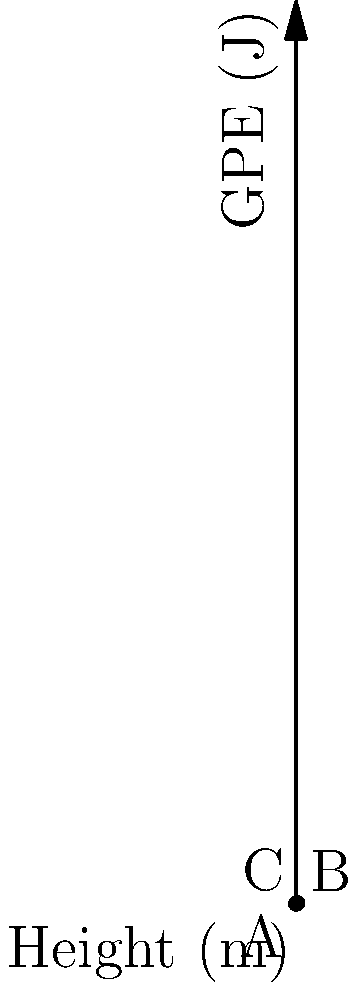A surfer of mass 70 kg is riding a wave as shown in the diagram. Calculate the difference in gravitational potential energy between points C and B. Assume $g = 9.8 \, \text{m/s}^2$. To solve this problem, we'll use the formula for gravitational potential energy (GPE):

$$\text{GPE} = mgh$$

where $m$ is mass, $g$ is acceleration due to gravity, and $h$ is height.

Steps:
1. Identify the heights of points C and B:
   Point C: $h_C = 4 \, \text{m}$
   Point B: $h_B = 2 \, \text{m}$

2. Calculate GPE at point C:
   $$\text{GPE}_C = 70 \, \text{kg} \times 9.8 \, \text{m/s}^2 \times 4 \, \text{m} = 2744 \, \text{J}$$

3. Calculate GPE at point B:
   $$\text{GPE}_B = 70 \, \text{kg} \times 9.8 \, \text{m/s}^2 \times 2 \, \text{m} = 1372 \, \text{J}$$

4. Find the difference in GPE:
   $$\Delta \text{GPE} = \text{GPE}_C - \text{GPE}_B = 2744 \, \text{J} - 1372 \, \text{J} = 1372 \, \text{J}$$

Therefore, the difference in gravitational potential energy between points C and B is 1372 J.
Answer: 1372 J 